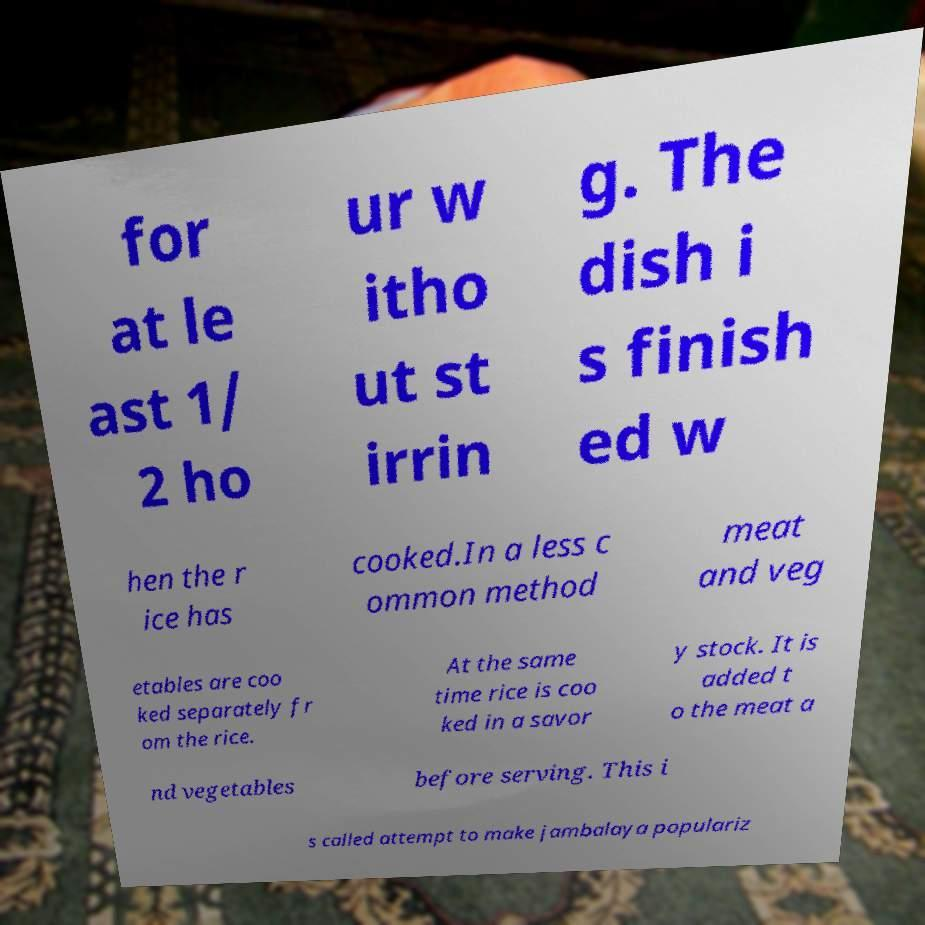Please read and relay the text visible in this image. What does it say? for at le ast 1/ 2 ho ur w itho ut st irrin g. The dish i s finish ed w hen the r ice has cooked.In a less c ommon method meat and veg etables are coo ked separately fr om the rice. At the same time rice is coo ked in a savor y stock. It is added t o the meat a nd vegetables before serving. This i s called attempt to make jambalaya populariz 